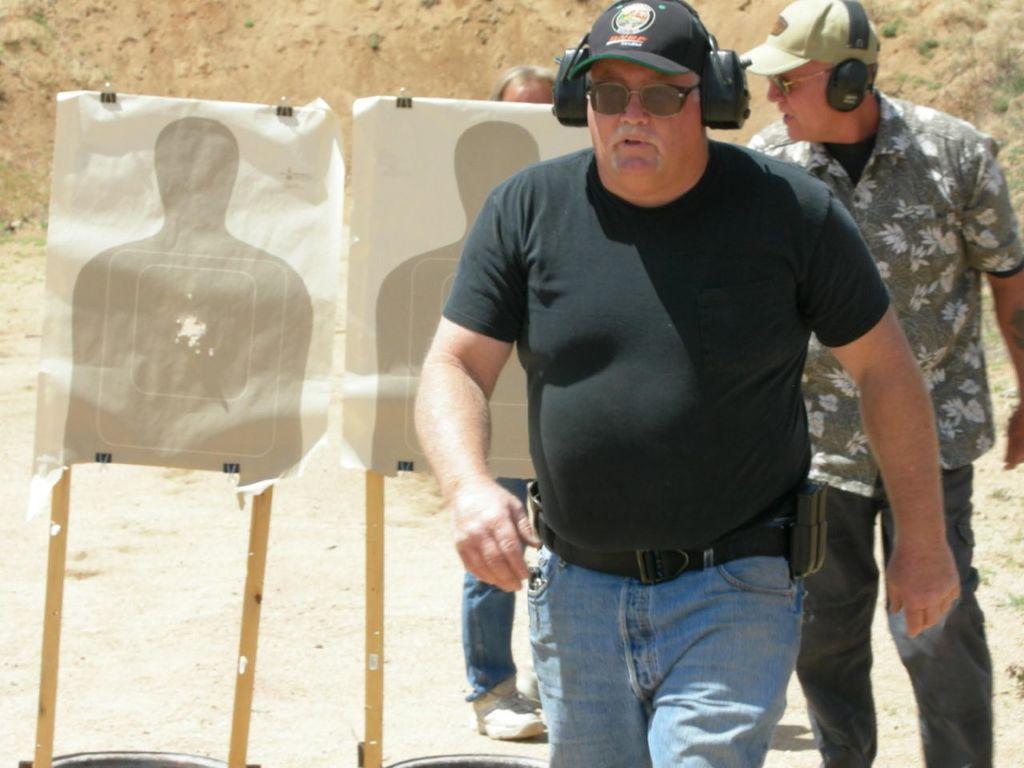Can you describe this image briefly? This picture is taken from outside of the city. In this image, on the right side, we can see a man wearing black color shirt and keeping headphones is walking. On the right side, we can also see another man wearing cap and keeping headphones. In the background, we can see two charts on the painting board, on that chart, we can see person figure. In the background, we can also see another person, rocks, grass. At the bottom, we can see a land. 